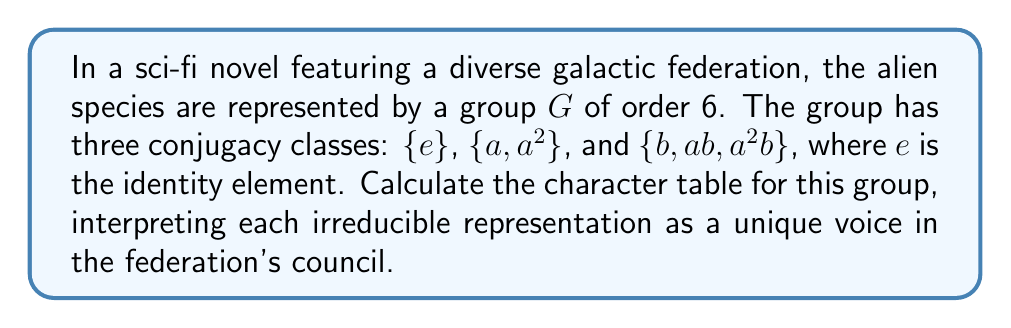Help me with this question. Let's approach this step-by-step:

1) First, we need to determine the number of irreducible representations. This is equal to the number of conjugacy classes, which is 3.

2) We know that the sum of squares of the dimensions of irreducible representations equals the order of the group:
   $$ d_1^2 + d_2^2 + d_3^2 = 6 $$

3) The only solution for this equation with positive integers is $1^2 + 1^2 + 2^2 = 6$. So we have two 1-dimensional representations and one 2-dimensional representation.

4) Let's call these representations $\chi_1$, $\chi_2$, and $\chi_3$ respectively.

5) $\chi_1$ is always the trivial representation, which assigns 1 to all elements.

6) For $\chi_2$, we know $\chi_2(e) = 1$. Since $a^3 = e$, $\chi_2(a)$ must be a cube root of unity. The only real cube root of unity other than 1 is -1. So $\chi_2(a) = -1$.

7) For $\chi_2(b)$, we know $b^2 = e$, so $\chi_2(b) = \pm 1$. But if $\chi_2(b) = 1$, then $\chi_2$ would be the trivial representation. So $\chi_2(b) = -1$.

8) For $\chi_3$, we can use the orthogonality relations. The sum of squares of entries in each column must equal 6:

   For $\{a, a^2\}$: $1^2 + (-1)^2 + \chi_3(a)^2 = 6$, so $\chi_3(a) = \pm\sqrt{4} = \pm 2$
   
   For $\{b, ab, a^2b\}$: $1^2 + (-1)^2 + \chi_3(b)^2 = 6$, so $\chi_3(b) = \pm\sqrt{4} = \pm 2$

9) The character of a 2-dimensional representation must have trace in the range [-2, 2], so $\chi_3(a) = -1$ and $\chi_3(b) = 0$.

Thus, the character table is:

$$ \begin{array}{c|ccc}
   & \{e\} & \{a, a^2\} & \{b, ab, a^2b\} \\
   \hline
   \chi_1 & 1 & 1 & 1 \\
   \chi_2 & 1 & -1 & -1 \\
   \chi_3 & 2 & -1 & 0
\end{array} $$
Answer: $$ \begin{array}{c|ccc}
   & \{e\} & \{a, a^2\} & \{b, ab, a^2b\} \\
   \hline
   \chi_1 & 1 & 1 & 1 \\
   \chi_2 & 1 & -1 & -1 \\
   \chi_3 & 2 & -1 & 0
\end{array} $$ 